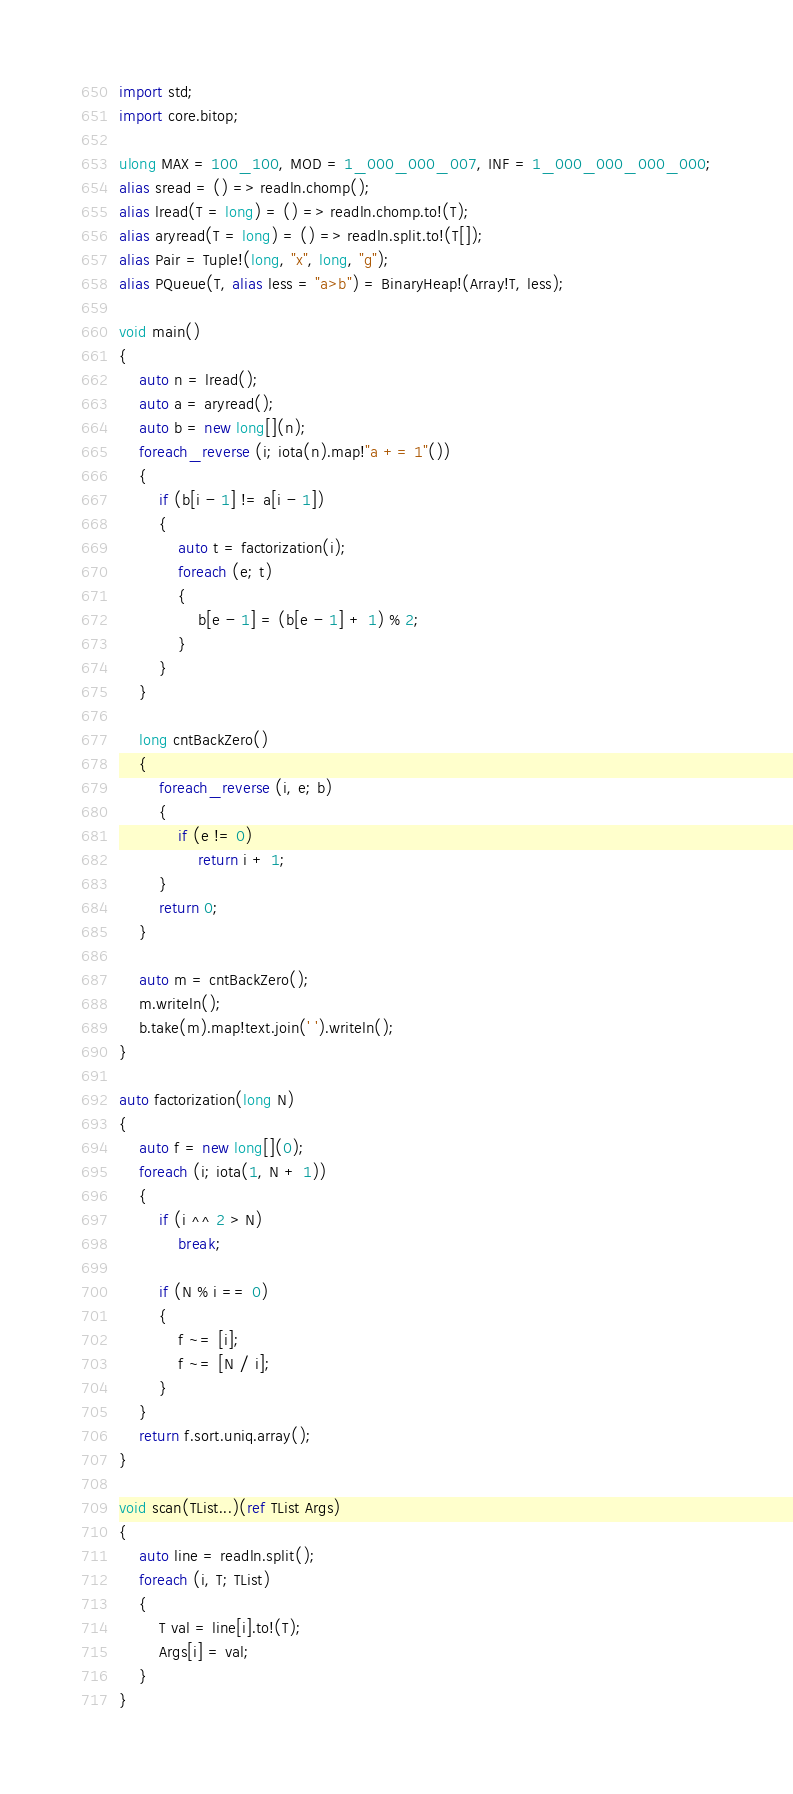Convert code to text. <code><loc_0><loc_0><loc_500><loc_500><_D_>import std;
import core.bitop;

ulong MAX = 100_100, MOD = 1_000_000_007, INF = 1_000_000_000_000;
alias sread = () => readln.chomp();
alias lread(T = long) = () => readln.chomp.to!(T);
alias aryread(T = long) = () => readln.split.to!(T[]);
alias Pair = Tuple!(long, "x", long, "g");
alias PQueue(T, alias less = "a>b") = BinaryHeap!(Array!T, less);

void main()
{
    auto n = lread();
    auto a = aryread();
    auto b = new long[](n);
    foreach_reverse (i; iota(n).map!"a += 1"())
    {
        if (b[i - 1] != a[i - 1])
        {
            auto t = factorization(i);
            foreach (e; t)
            {
                b[e - 1] = (b[e - 1] + 1) % 2;
            }
        }
    }

    long cntBackZero()
    {
        foreach_reverse (i, e; b)
        {
            if (e != 0)
                return i + 1;
        }
        return 0;
    }

    auto m = cntBackZero();
    m.writeln();
    b.take(m).map!text.join(' ').writeln();
}

auto factorization(long N)
{
    auto f = new long[](0);
    foreach (i; iota(1, N + 1))
    {
        if (i ^^ 2 > N)
            break;

        if (N % i == 0)
        {
            f ~= [i];
            f ~= [N / i];
        }
    }
    return f.sort.uniq.array();
}

void scan(TList...)(ref TList Args)
{
    auto line = readln.split();
    foreach (i, T; TList)
    {
        T val = line[i].to!(T);
        Args[i] = val;
    }
}
</code> 